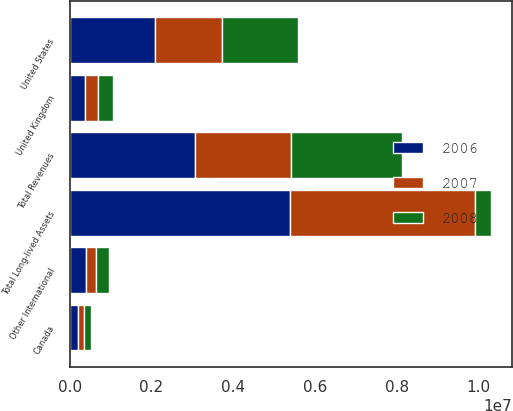Convert chart to OTSL. <chart><loc_0><loc_0><loc_500><loc_500><stacked_bar_chart><ecel><fcel>United States<fcel>United Kingdom<fcel>Canada<fcel>Other International<fcel>Total Revenues<fcel>Total Long-lived Assets<nl><fcel>2007<fcel>1.64726e+06<fcel>312393<fcel>154801<fcel>235883<fcel>2.35034e+06<fcel>4.5298e+06<nl><fcel>2008<fcel>1.86281e+06<fcel>368008<fcel>179636<fcel>319582<fcel>2.73004e+06<fcel>400251<nl><fcel>2006<fcel>2.07488e+06<fcel>382971<fcel>197031<fcel>400251<fcel>3.05513e+06<fcel>5.38046e+06<nl></chart> 